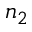<formula> <loc_0><loc_0><loc_500><loc_500>n _ { 2 }</formula> 